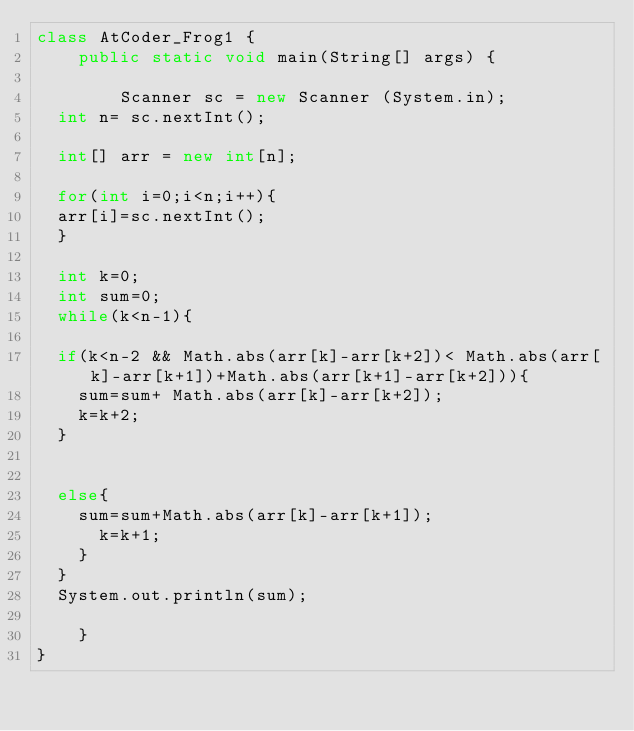<code> <loc_0><loc_0><loc_500><loc_500><_Java_>class AtCoder_Frog1 {
    public static void main(String[] args) {
         
        Scanner sc = new Scanner (System.in);
  int n= sc.nextInt();
  
  int[] arr = new int[n];
  
  for(int i=0;i<n;i++){
  arr[i]=sc.nextInt();
  }
  
  int k=0;
  int sum=0;
  while(k<n-1){
  
  if(k<n-2 && Math.abs(arr[k]-arr[k+2])< Math.abs(arr[k]-arr[k+1])+Math.abs(arr[k+1]-arr[k+2])){
    sum=sum+ Math.abs(arr[k]-arr[k+2]);
    k=k+2;
  }
  
    
  else{
    sum=sum+Math.abs(arr[k]-arr[k+1]);
      k=k+1;
    }
  }
  System.out.println(sum);
    
    } 
}
</code> 